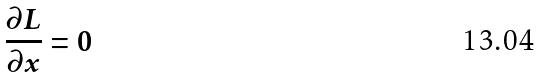<formula> <loc_0><loc_0><loc_500><loc_500>\frac { \partial L } { \partial x } = 0</formula> 